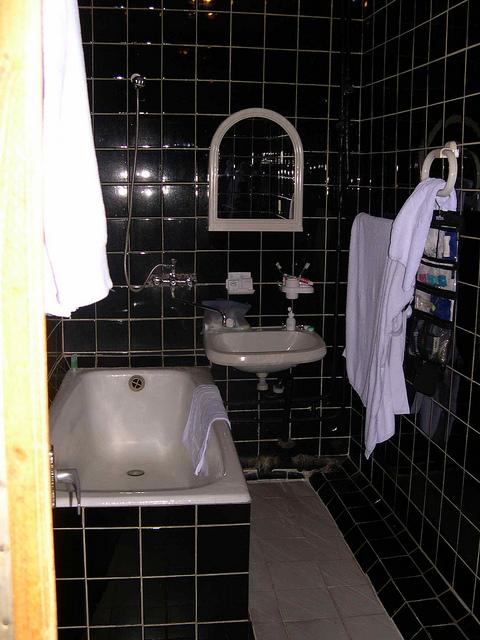Is the bathroom clean?
Give a very brief answer. Yes. What color are the tiles?
Keep it brief. Black. Is a toilet shown?
Keep it brief. No. 